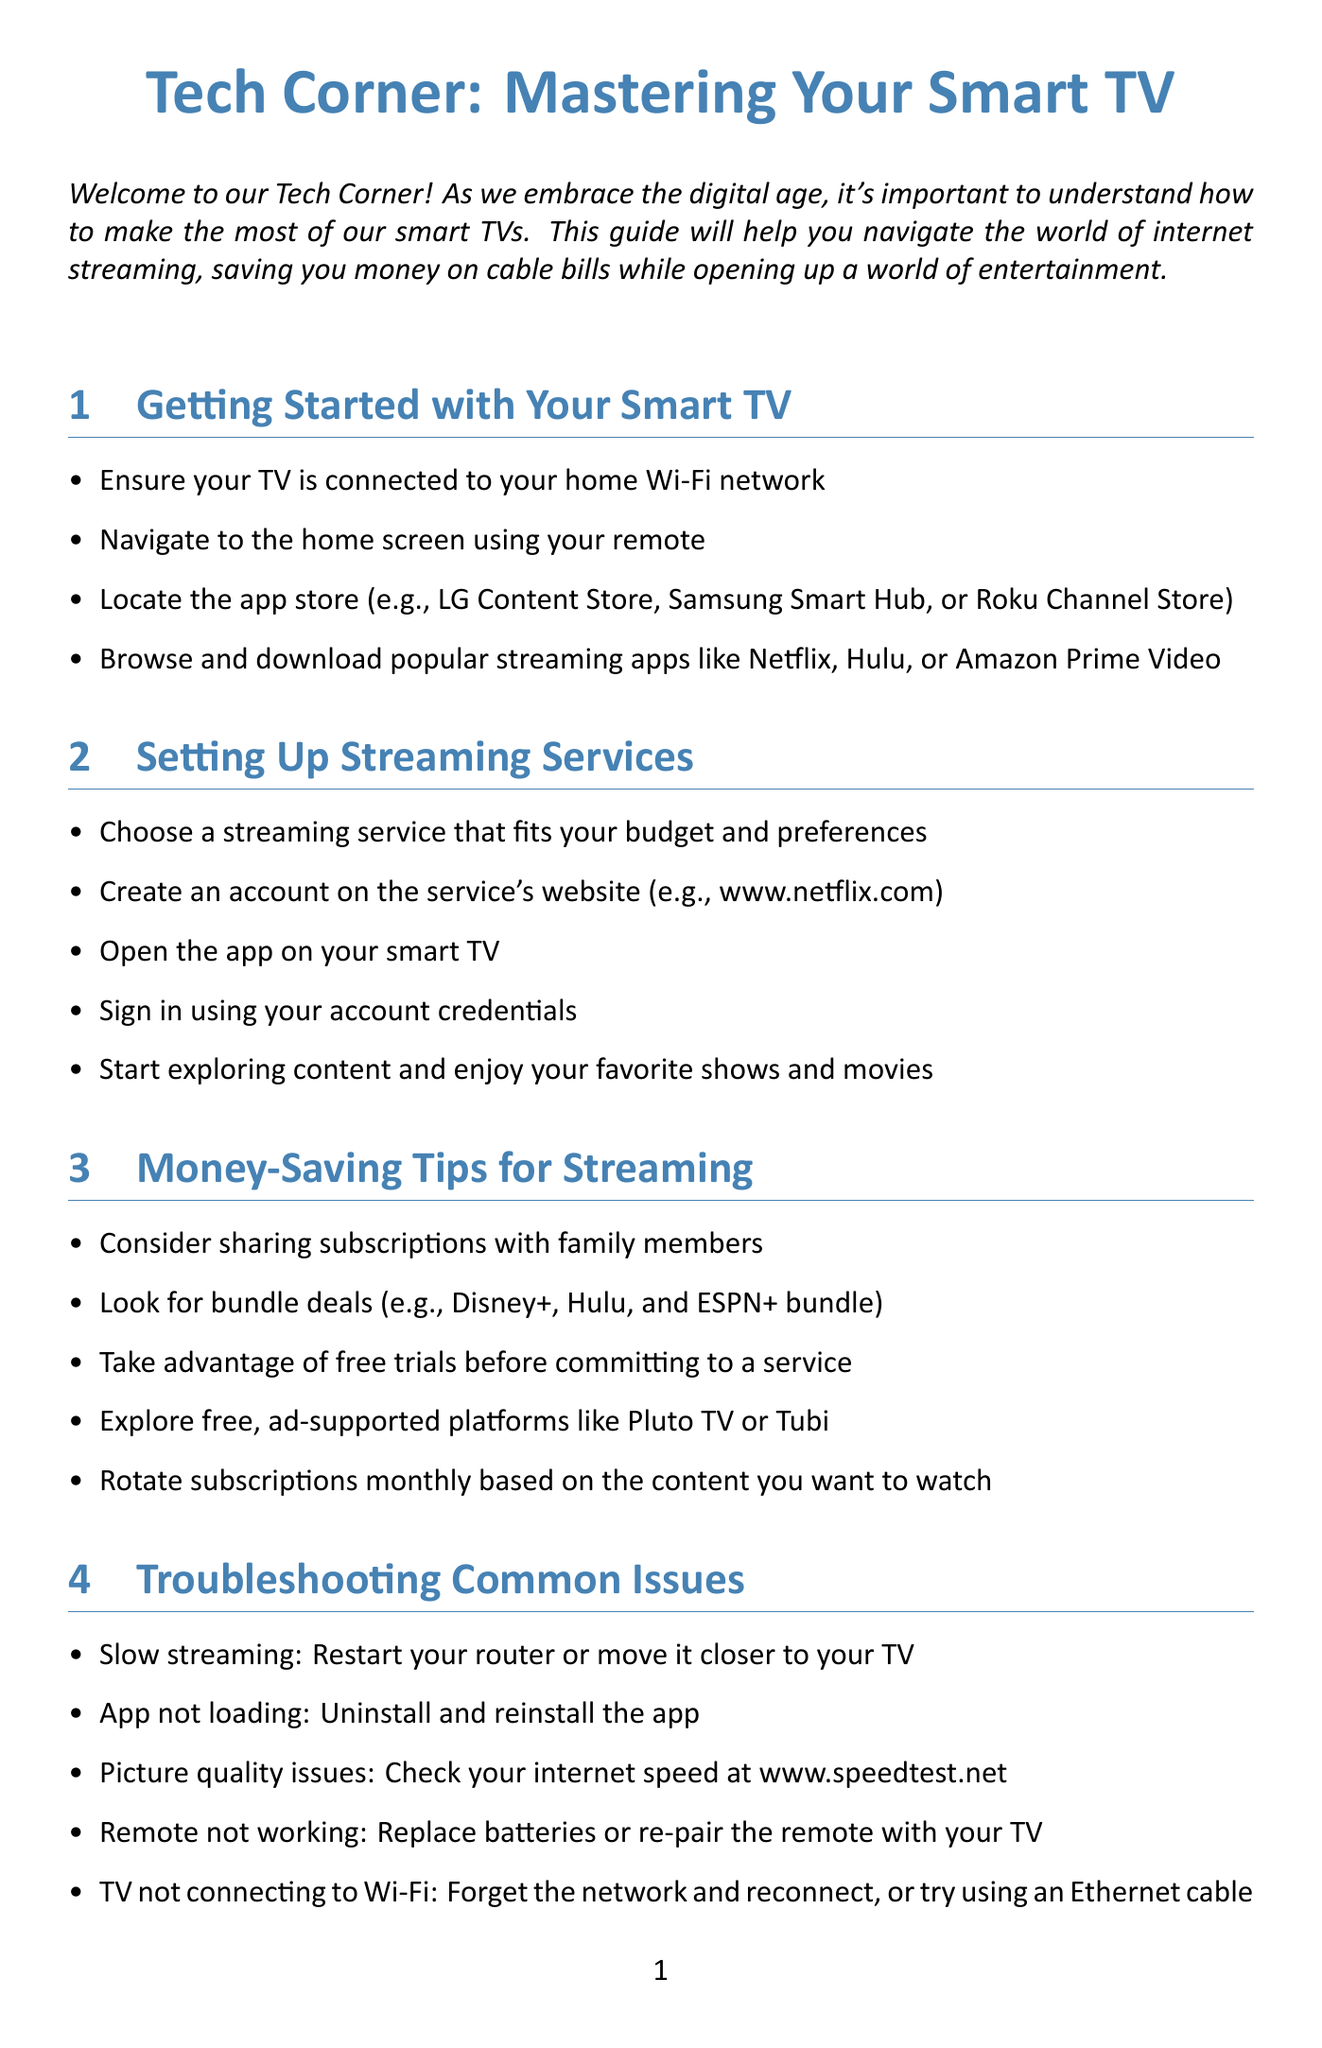What is the title of the newsletter? The title of the newsletter is mentioned at the beginning.
Answer: Tech Corner: Mastering Your Smart TV How many sections are in the newsletter? The document lists five sections in the content.
Answer: Five What should you do if your app is not loading? This information is found in the troubleshooting section.
Answer: Uninstall and reinstall the app What is one platform mentioned for free, ad-supported streaming? The document mentions examples of free platforms in the money-saving tips.
Answer: Pluto TV What feature can you enable to assist with viewing for seniors? This information is in the accessibility features section.
Answer: Closed captions What should you check for picture quality issues? The document suggests checking internet speed for this issue.
Answer: Internet speed What is a recommended strategy to save on subscriptions? This recommendation appears in the money-saving tips section.
Answer: Rotate subscriptions monthly based on content What is the first step in getting started with your Smart TV? The first step is mentioned in the getting started section.
Answer: Ensure your TV is connected to your home Wi-Fi network 